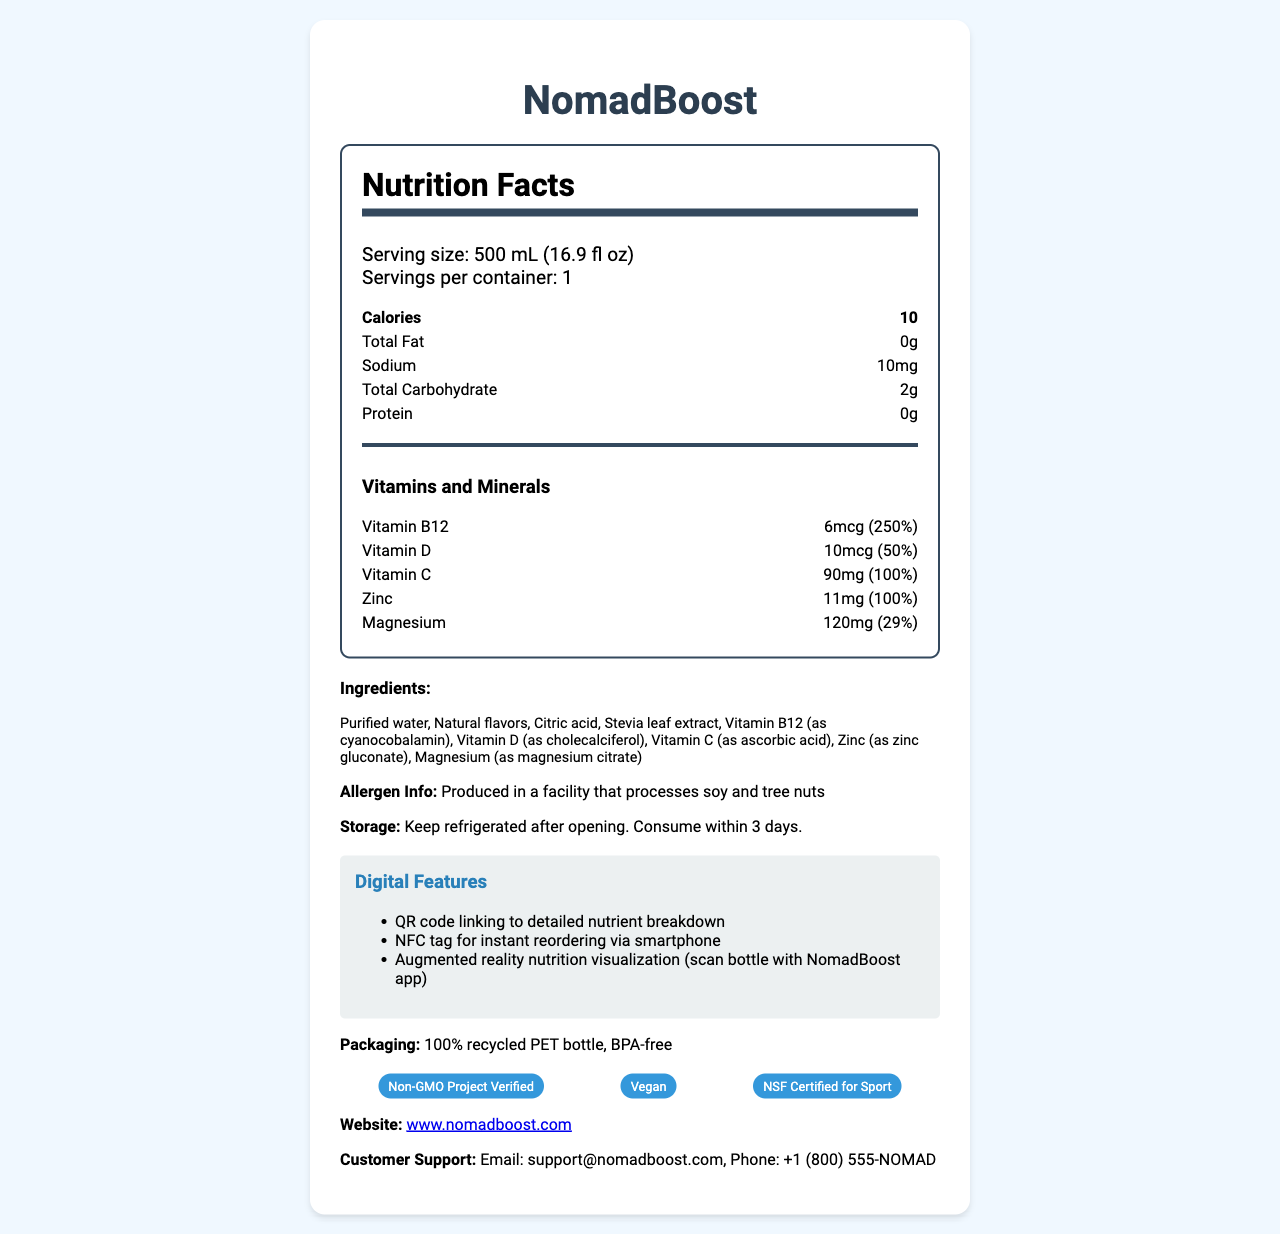what is the name of the product? The name of the product is prominently displayed at the top of the document, labeled "NomadBoost".
Answer: NomadBoost what is the serving size? The serving size is mentioned in the serving information section as "500 mL (16.9 fl oz)".
Answer: 500 mL (16.9 fl oz) how many servings are in one container? The document states that there is 1 serving per container.
Answer: 1 how many calories are in one serving? The calories per serving are listed as 10 in the Nutrition Facts section.
Answer: 10 calories which vitamins and minerals are included in the product? The Vitamins and Minerals section of the nutrition label lists Vitamin B12, Vitamin D, Vitamin C, Zinc, and Magnesium.
Answer: Vitamin B12, Vitamin D, Vitamin C, Zinc, Magnesium where can you find detailed nutrient information for this product? The document mentions a QR code linking to detailed nutrient breakdown as part of the digital features.
Answer: By scanning the QR code on the bottle what should you do with the product after opening it? The storage instructions specify that the product should be kept refrigerated after opening and consumed within 3 days.
Answer: Keep refrigerated and consume within 3 days which of the following is not listed as an ingredient? A. Purified water B. Cane sugar C. Stevia leaf extract D. Citric acid Cane sugar is not mentioned in the ingredients list, while purified water, stevia leaf extract, and citric acid are.
Answer: B. Cane sugar what certifications does the product have? The certifications section lists these three certifications.
Answer: Non-GMO Project Verified, Vegan, NSF Certified for Sport what kind of packaging is used for the product? The packaging information states that it is a 100% recycled PET bottle and BPA-free.
Answer: 100% recycled PET bottle, BPA-free does the product support immune function and energy levels? This is one of the marketing claims listed in the document.
Answer: Yes what special feature does the product offer for instant reordering? A. QR code B. Website link C. NFC tag D. Customer support phone The digital features mention an NFC tag for instant reordering via smartphone.
Answer: C. NFC tag does the product contain any ingredients from tree nuts? The allergen info specifies that the product is produced in a facility that processes soy and tree nuts, but it does not list tree nuts as an ingredient.
Answer: No, but it is produced in a facility that processes soy and tree nuts summarize the main features and benefits of NomadBoost bottled water NomadBoost caters to digital nomads with a focus on health and convenience. Its nutritional profile includes essential vitamins and minerals, with additional digital features for enhanced user experience and sustainability practices. The product's marketing claims highlight its benefits for immune support, energy, focus, hydration, and cognitive performance.
Answer: NomadBoost is a vitamin-fortified bottled water designed for digital nomads. It offers numerous health benefits such as supporting immune function, energy levels, focus, hydration, and cognitive performance. It contains vitamins and minerals like Vitamin B12, Vitamin D, Vitamin C, Zinc, and Magnesium. The product is low in calories and uses eco-friendly packaging. It includes digital features like a QR code, NFC tag, and augmented reality visualization. Certifications include Non-GMO Project Verified, Vegan, and NSF Certified for Sport. who is the target audience for NomadBoost? The product is specifically designed for digital nomads, as stated in the marketing claims.
Answer: Digital nomads how many milligrams of sodium does NomadBoost contain per serving? According to the nutrition facts, NomadBoost contains 10 mg of sodium per serving.
Answer: 10 mg can you reorder NomadBoost without visiting the website or store? The NFC tag feature allows for instant reordering via smartphone.
Answer: Yes is NomadBoost certified organic? The document lists certifications like Non-GMO Project Verified, Vegan, and NSF Certified for Sport, but does not mention an organic certification.
Answer: Cannot be determined 